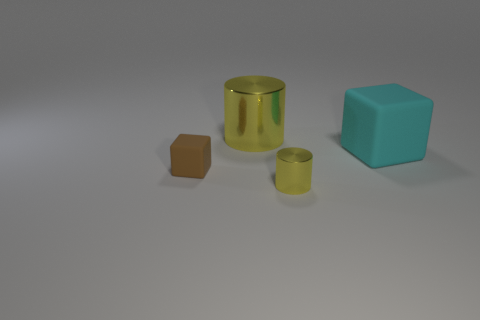Do the brown matte object and the cyan thing have the same size?
Your answer should be very brief. No. What material is the yellow cylinder to the left of the yellow thing that is in front of the large cyan rubber cube?
Your answer should be very brief. Metal. How many big objects have the same color as the small metal cylinder?
Give a very brief answer. 1. Are there any other things that have the same material as the tiny cylinder?
Your answer should be compact. Yes. Is the number of tiny cylinders on the right side of the small cylinder less than the number of big green blocks?
Ensure brevity in your answer.  No. There is a matte cube that is to the right of the yellow thing that is behind the small cube; what color is it?
Make the answer very short. Cyan. There is a yellow object in front of the cylinder behind the rubber thing that is behind the brown block; how big is it?
Offer a terse response. Small. Is the number of shiny objects that are to the right of the cyan cube less than the number of rubber cubes that are right of the brown cube?
Give a very brief answer. Yes. How many tiny brown objects are the same material as the cyan cube?
Give a very brief answer. 1. There is a shiny cylinder that is in front of the matte thing behind the brown cube; are there any small brown objects on the right side of it?
Give a very brief answer. No. 